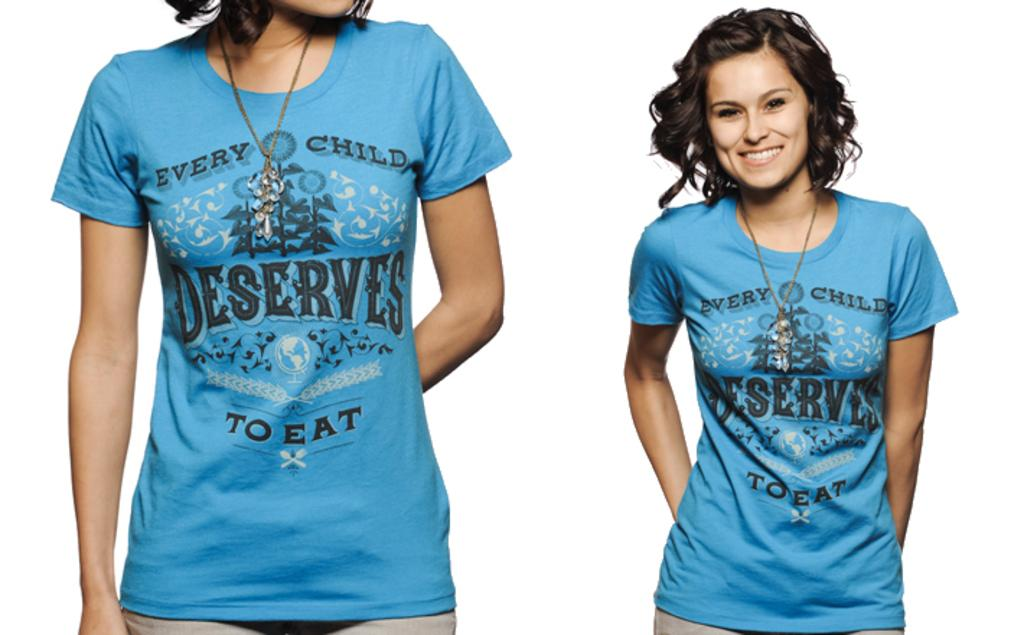Provide a one-sentence caption for the provided image. a woman in a shirt that reads: every child deserves to eat. 